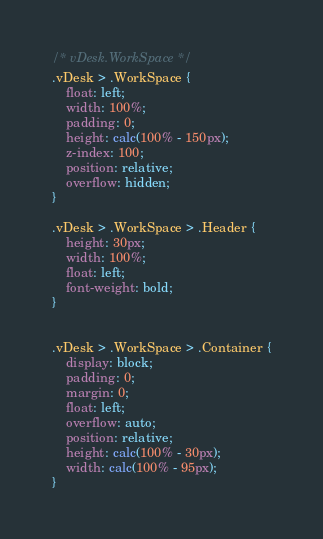Convert code to text. <code><loc_0><loc_0><loc_500><loc_500><_CSS_>/* vDesk.WorkSpace */
.vDesk > .WorkSpace {
    float: left;
    width: 100%;
    padding: 0;
    height: calc(100% - 150px);
    z-index: 100;
    position: relative;
    overflow: hidden;
}

.vDesk > .WorkSpace > .Header {
    height: 30px;
    width: 100%;
    float: left;
    font-weight: bold;
}


.vDesk > .WorkSpace > .Container {
    display: block;
    padding: 0;
    margin: 0;
    float: left;
    overflow: auto;
    position: relative;
    height: calc(100% - 30px);
    width: calc(100% - 95px);
}</code> 